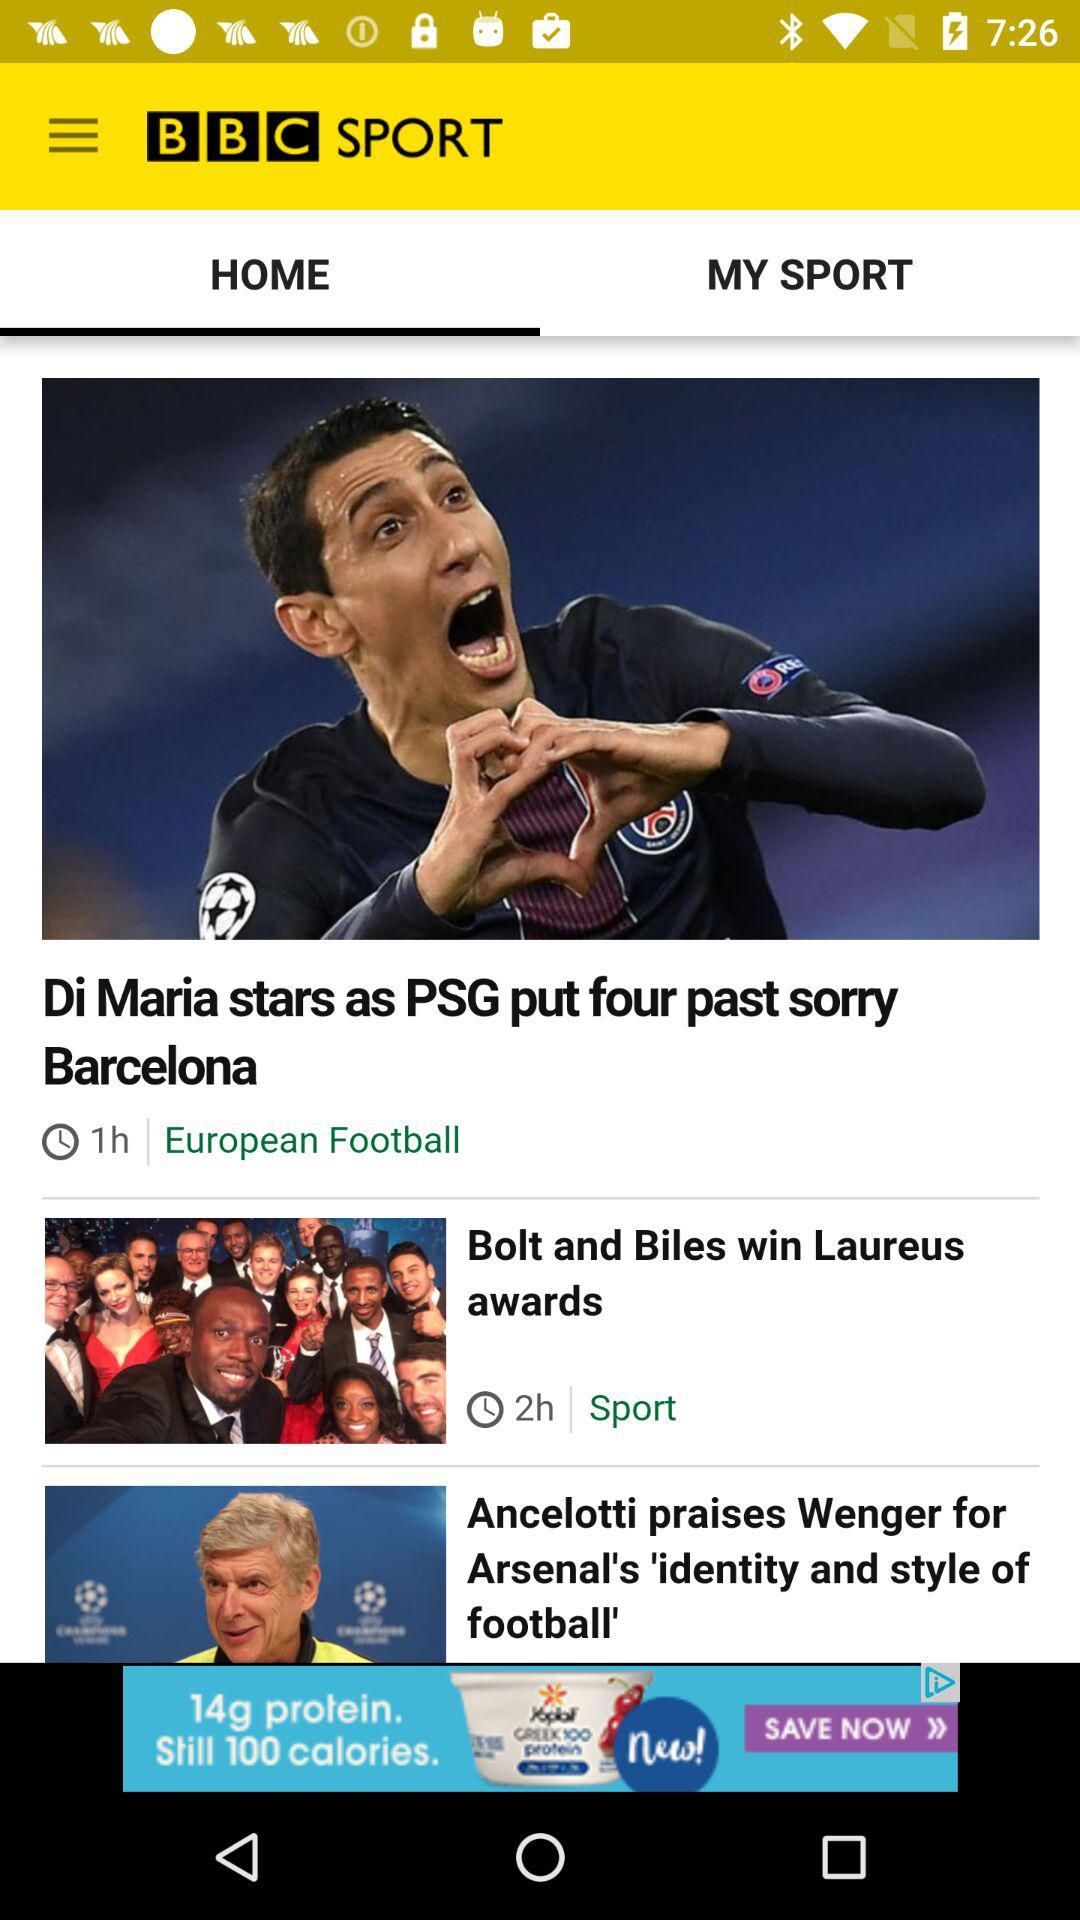What is the name of the application? The name of the application is "BBC SPORT". 